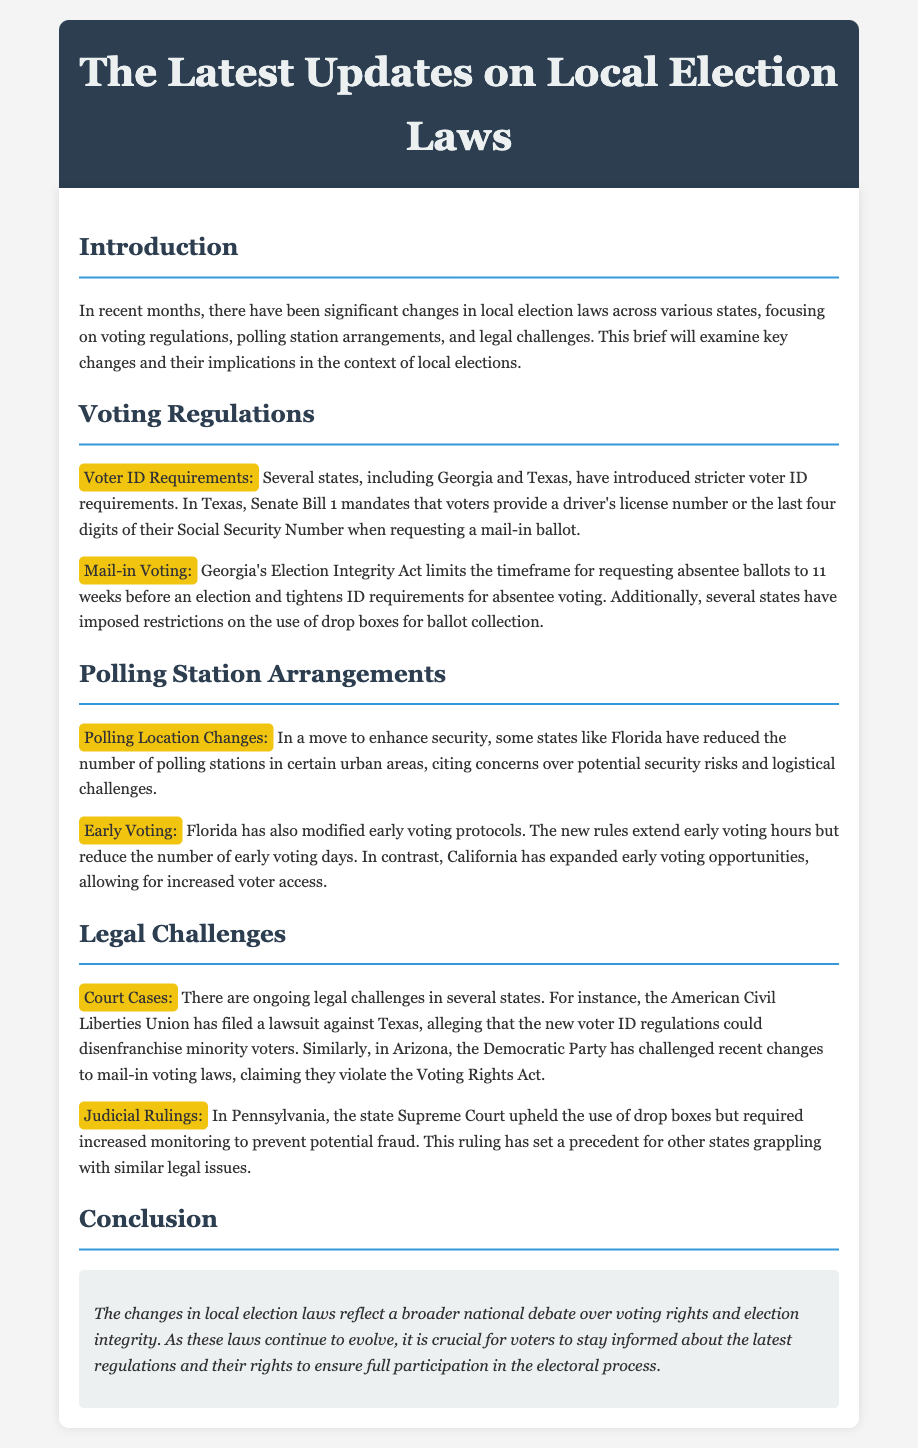What are the new voter ID requirements in Texas? Texas mandates that voters provide a driver's license number or the last four digits of their Social Security Number when requesting a mail-in ballot.
Answer: driver's license number or the last four digits of their Social Security Number How has Georgia changed absentee ballot request timelines? Georgia's Election Integrity Act limits the timeframe for requesting absentee ballots to 11 weeks before an election.
Answer: 11 weeks Which state has reduced the number of polling stations in urban areas? Florida has reduced the number of polling stations in certain urban areas.
Answer: Florida What organization filed a lawsuit against Texas regarding voter ID regulations? The American Civil Liberties Union has filed a lawsuit against Texas.
Answer: American Civil Liberties Union What change has California made regarding early voting? California has expanded early voting opportunities, allowing for increased voter access.
Answer: expanded early voting opportunities What did the Pennsylvania Supreme Court uphold regarding drop boxes? The state Supreme Court upheld the use of drop boxes but required increased monitoring to prevent potential fraud.
Answer: increased monitoring What does the conclusion emphasize? The conclusion emphasizes the importance of voters staying informed about the latest regulations and their rights.
Answer: staying informed about the latest regulations and their rights Which party challenged mail-in voting changes in Arizona? The Democratic Party has challenged recent changes to mail-in voting laws in Arizona.
Answer: Democratic Party 